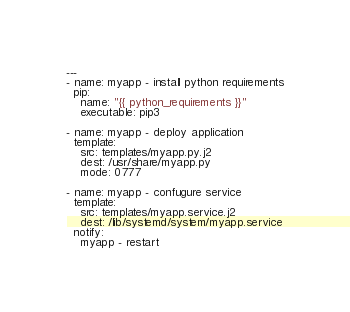<code> <loc_0><loc_0><loc_500><loc_500><_YAML_>---
- name: myapp - install python requirements
  pip:
    name: "{{ python_requirements }}"
    executable: pip3

- name: myapp - deploy application
  template:
    src: templates/myapp.py.j2
    dest: /usr/share/myapp.py
    mode: 0777

- name: myapp - confugure service
  template:
    src: templates/myapp.service.j2
    dest: /lib/systemd/system/myapp.service
  notify:
    myapp - restart
</code> 